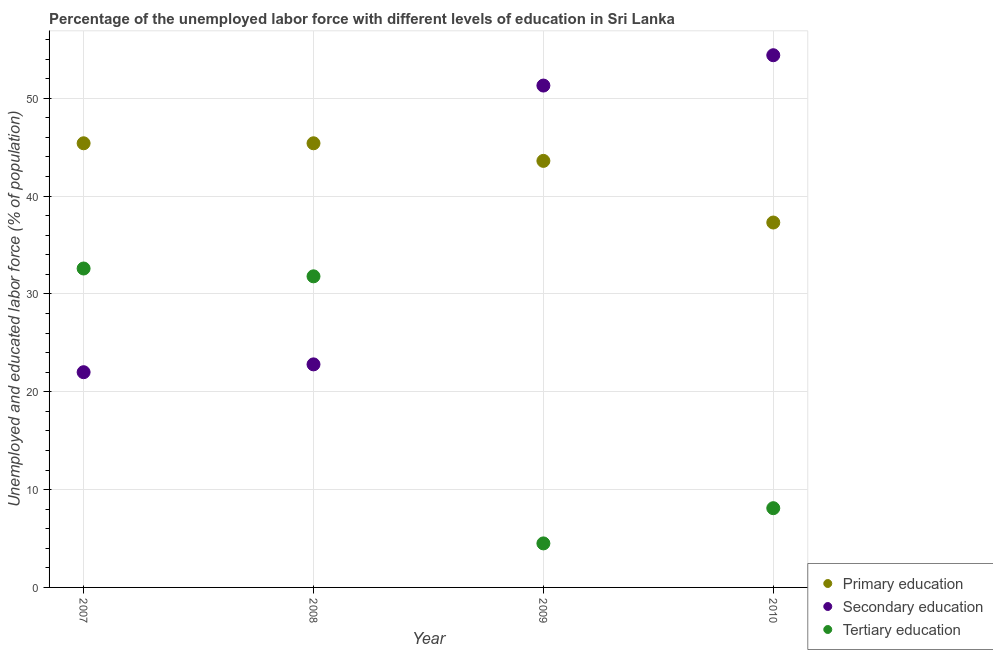How many different coloured dotlines are there?
Give a very brief answer. 3. Across all years, what is the maximum percentage of labor force who received secondary education?
Make the answer very short. 54.4. Across all years, what is the minimum percentage of labor force who received primary education?
Offer a very short reply. 37.3. What is the total percentage of labor force who received primary education in the graph?
Provide a succinct answer. 171.7. What is the difference between the percentage of labor force who received tertiary education in 2007 and that in 2009?
Keep it short and to the point. 28.1. What is the difference between the percentage of labor force who received primary education in 2007 and the percentage of labor force who received secondary education in 2009?
Offer a very short reply. -5.9. What is the average percentage of labor force who received secondary education per year?
Provide a succinct answer. 37.62. In the year 2008, what is the difference between the percentage of labor force who received primary education and percentage of labor force who received secondary education?
Provide a short and direct response. 22.6. What is the ratio of the percentage of labor force who received primary education in 2008 to that in 2010?
Offer a very short reply. 1.22. Is the percentage of labor force who received tertiary education in 2009 less than that in 2010?
Your answer should be compact. Yes. Is the difference between the percentage of labor force who received primary education in 2009 and 2010 greater than the difference between the percentage of labor force who received secondary education in 2009 and 2010?
Make the answer very short. Yes. What is the difference between the highest and the second highest percentage of labor force who received tertiary education?
Offer a terse response. 0.8. What is the difference between the highest and the lowest percentage of labor force who received primary education?
Give a very brief answer. 8.1. In how many years, is the percentage of labor force who received primary education greater than the average percentage of labor force who received primary education taken over all years?
Provide a succinct answer. 3. Is it the case that in every year, the sum of the percentage of labor force who received primary education and percentage of labor force who received secondary education is greater than the percentage of labor force who received tertiary education?
Make the answer very short. Yes. Does the percentage of labor force who received primary education monotonically increase over the years?
Ensure brevity in your answer.  No. Is the percentage of labor force who received primary education strictly less than the percentage of labor force who received tertiary education over the years?
Provide a succinct answer. No. How many dotlines are there?
Offer a terse response. 3. How many years are there in the graph?
Offer a very short reply. 4. Are the values on the major ticks of Y-axis written in scientific E-notation?
Offer a very short reply. No. Does the graph contain any zero values?
Keep it short and to the point. No. Where does the legend appear in the graph?
Your answer should be very brief. Bottom right. How are the legend labels stacked?
Your response must be concise. Vertical. What is the title of the graph?
Give a very brief answer. Percentage of the unemployed labor force with different levels of education in Sri Lanka. Does "Wage workers" appear as one of the legend labels in the graph?
Ensure brevity in your answer.  No. What is the label or title of the X-axis?
Your response must be concise. Year. What is the label or title of the Y-axis?
Provide a succinct answer. Unemployed and educated labor force (% of population). What is the Unemployed and educated labor force (% of population) of Primary education in 2007?
Offer a very short reply. 45.4. What is the Unemployed and educated labor force (% of population) of Secondary education in 2007?
Provide a short and direct response. 22. What is the Unemployed and educated labor force (% of population) in Tertiary education in 2007?
Your response must be concise. 32.6. What is the Unemployed and educated labor force (% of population) in Primary education in 2008?
Your response must be concise. 45.4. What is the Unemployed and educated labor force (% of population) of Secondary education in 2008?
Your response must be concise. 22.8. What is the Unemployed and educated labor force (% of population) of Tertiary education in 2008?
Keep it short and to the point. 31.8. What is the Unemployed and educated labor force (% of population) in Primary education in 2009?
Keep it short and to the point. 43.6. What is the Unemployed and educated labor force (% of population) in Secondary education in 2009?
Keep it short and to the point. 51.3. What is the Unemployed and educated labor force (% of population) of Tertiary education in 2009?
Make the answer very short. 4.5. What is the Unemployed and educated labor force (% of population) in Primary education in 2010?
Ensure brevity in your answer.  37.3. What is the Unemployed and educated labor force (% of population) of Secondary education in 2010?
Offer a very short reply. 54.4. What is the Unemployed and educated labor force (% of population) in Tertiary education in 2010?
Your answer should be compact. 8.1. Across all years, what is the maximum Unemployed and educated labor force (% of population) of Primary education?
Provide a short and direct response. 45.4. Across all years, what is the maximum Unemployed and educated labor force (% of population) in Secondary education?
Your answer should be very brief. 54.4. Across all years, what is the maximum Unemployed and educated labor force (% of population) of Tertiary education?
Offer a very short reply. 32.6. Across all years, what is the minimum Unemployed and educated labor force (% of population) of Primary education?
Give a very brief answer. 37.3. What is the total Unemployed and educated labor force (% of population) in Primary education in the graph?
Offer a terse response. 171.7. What is the total Unemployed and educated labor force (% of population) of Secondary education in the graph?
Your answer should be very brief. 150.5. What is the difference between the Unemployed and educated labor force (% of population) in Secondary education in 2007 and that in 2008?
Your answer should be very brief. -0.8. What is the difference between the Unemployed and educated labor force (% of population) in Tertiary education in 2007 and that in 2008?
Your response must be concise. 0.8. What is the difference between the Unemployed and educated labor force (% of population) of Primary education in 2007 and that in 2009?
Ensure brevity in your answer.  1.8. What is the difference between the Unemployed and educated labor force (% of population) in Secondary education in 2007 and that in 2009?
Provide a short and direct response. -29.3. What is the difference between the Unemployed and educated labor force (% of population) in Tertiary education in 2007 and that in 2009?
Give a very brief answer. 28.1. What is the difference between the Unemployed and educated labor force (% of population) in Primary education in 2007 and that in 2010?
Offer a very short reply. 8.1. What is the difference between the Unemployed and educated labor force (% of population) in Secondary education in 2007 and that in 2010?
Provide a succinct answer. -32.4. What is the difference between the Unemployed and educated labor force (% of population) in Tertiary education in 2007 and that in 2010?
Your answer should be very brief. 24.5. What is the difference between the Unemployed and educated labor force (% of population) in Secondary education in 2008 and that in 2009?
Ensure brevity in your answer.  -28.5. What is the difference between the Unemployed and educated labor force (% of population) of Tertiary education in 2008 and that in 2009?
Give a very brief answer. 27.3. What is the difference between the Unemployed and educated labor force (% of population) of Primary education in 2008 and that in 2010?
Your answer should be compact. 8.1. What is the difference between the Unemployed and educated labor force (% of population) of Secondary education in 2008 and that in 2010?
Give a very brief answer. -31.6. What is the difference between the Unemployed and educated labor force (% of population) of Tertiary education in 2008 and that in 2010?
Your answer should be very brief. 23.7. What is the difference between the Unemployed and educated labor force (% of population) of Primary education in 2009 and that in 2010?
Ensure brevity in your answer.  6.3. What is the difference between the Unemployed and educated labor force (% of population) of Secondary education in 2009 and that in 2010?
Your response must be concise. -3.1. What is the difference between the Unemployed and educated labor force (% of population) of Tertiary education in 2009 and that in 2010?
Your answer should be compact. -3.6. What is the difference between the Unemployed and educated labor force (% of population) of Primary education in 2007 and the Unemployed and educated labor force (% of population) of Secondary education in 2008?
Give a very brief answer. 22.6. What is the difference between the Unemployed and educated labor force (% of population) of Secondary education in 2007 and the Unemployed and educated labor force (% of population) of Tertiary education in 2008?
Make the answer very short. -9.8. What is the difference between the Unemployed and educated labor force (% of population) of Primary education in 2007 and the Unemployed and educated labor force (% of population) of Tertiary education in 2009?
Your response must be concise. 40.9. What is the difference between the Unemployed and educated labor force (% of population) in Secondary education in 2007 and the Unemployed and educated labor force (% of population) in Tertiary education in 2009?
Offer a terse response. 17.5. What is the difference between the Unemployed and educated labor force (% of population) of Primary education in 2007 and the Unemployed and educated labor force (% of population) of Secondary education in 2010?
Your response must be concise. -9. What is the difference between the Unemployed and educated labor force (% of population) in Primary education in 2007 and the Unemployed and educated labor force (% of population) in Tertiary education in 2010?
Offer a very short reply. 37.3. What is the difference between the Unemployed and educated labor force (% of population) in Secondary education in 2007 and the Unemployed and educated labor force (% of population) in Tertiary education in 2010?
Make the answer very short. 13.9. What is the difference between the Unemployed and educated labor force (% of population) of Primary education in 2008 and the Unemployed and educated labor force (% of population) of Secondary education in 2009?
Make the answer very short. -5.9. What is the difference between the Unemployed and educated labor force (% of population) in Primary education in 2008 and the Unemployed and educated labor force (% of population) in Tertiary education in 2009?
Provide a short and direct response. 40.9. What is the difference between the Unemployed and educated labor force (% of population) in Primary education in 2008 and the Unemployed and educated labor force (% of population) in Secondary education in 2010?
Your response must be concise. -9. What is the difference between the Unemployed and educated labor force (% of population) in Primary education in 2008 and the Unemployed and educated labor force (% of population) in Tertiary education in 2010?
Your answer should be very brief. 37.3. What is the difference between the Unemployed and educated labor force (% of population) of Secondary education in 2008 and the Unemployed and educated labor force (% of population) of Tertiary education in 2010?
Your answer should be very brief. 14.7. What is the difference between the Unemployed and educated labor force (% of population) in Primary education in 2009 and the Unemployed and educated labor force (% of population) in Tertiary education in 2010?
Provide a short and direct response. 35.5. What is the difference between the Unemployed and educated labor force (% of population) of Secondary education in 2009 and the Unemployed and educated labor force (% of population) of Tertiary education in 2010?
Provide a short and direct response. 43.2. What is the average Unemployed and educated labor force (% of population) of Primary education per year?
Provide a succinct answer. 42.92. What is the average Unemployed and educated labor force (% of population) of Secondary education per year?
Offer a very short reply. 37.62. What is the average Unemployed and educated labor force (% of population) in Tertiary education per year?
Provide a short and direct response. 19.25. In the year 2007, what is the difference between the Unemployed and educated labor force (% of population) of Primary education and Unemployed and educated labor force (% of population) of Secondary education?
Provide a short and direct response. 23.4. In the year 2008, what is the difference between the Unemployed and educated labor force (% of population) of Primary education and Unemployed and educated labor force (% of population) of Secondary education?
Give a very brief answer. 22.6. In the year 2008, what is the difference between the Unemployed and educated labor force (% of population) of Primary education and Unemployed and educated labor force (% of population) of Tertiary education?
Give a very brief answer. 13.6. In the year 2008, what is the difference between the Unemployed and educated labor force (% of population) of Secondary education and Unemployed and educated labor force (% of population) of Tertiary education?
Provide a succinct answer. -9. In the year 2009, what is the difference between the Unemployed and educated labor force (% of population) in Primary education and Unemployed and educated labor force (% of population) in Tertiary education?
Your answer should be very brief. 39.1. In the year 2009, what is the difference between the Unemployed and educated labor force (% of population) in Secondary education and Unemployed and educated labor force (% of population) in Tertiary education?
Your answer should be very brief. 46.8. In the year 2010, what is the difference between the Unemployed and educated labor force (% of population) of Primary education and Unemployed and educated labor force (% of population) of Secondary education?
Ensure brevity in your answer.  -17.1. In the year 2010, what is the difference between the Unemployed and educated labor force (% of population) in Primary education and Unemployed and educated labor force (% of population) in Tertiary education?
Make the answer very short. 29.2. In the year 2010, what is the difference between the Unemployed and educated labor force (% of population) in Secondary education and Unemployed and educated labor force (% of population) in Tertiary education?
Provide a succinct answer. 46.3. What is the ratio of the Unemployed and educated labor force (% of population) of Primary education in 2007 to that in 2008?
Offer a terse response. 1. What is the ratio of the Unemployed and educated labor force (% of population) of Secondary education in 2007 to that in 2008?
Give a very brief answer. 0.96. What is the ratio of the Unemployed and educated labor force (% of population) in Tertiary education in 2007 to that in 2008?
Make the answer very short. 1.03. What is the ratio of the Unemployed and educated labor force (% of population) in Primary education in 2007 to that in 2009?
Ensure brevity in your answer.  1.04. What is the ratio of the Unemployed and educated labor force (% of population) in Secondary education in 2007 to that in 2009?
Give a very brief answer. 0.43. What is the ratio of the Unemployed and educated labor force (% of population) of Tertiary education in 2007 to that in 2009?
Provide a succinct answer. 7.24. What is the ratio of the Unemployed and educated labor force (% of population) of Primary education in 2007 to that in 2010?
Give a very brief answer. 1.22. What is the ratio of the Unemployed and educated labor force (% of population) in Secondary education in 2007 to that in 2010?
Your answer should be compact. 0.4. What is the ratio of the Unemployed and educated labor force (% of population) of Tertiary education in 2007 to that in 2010?
Make the answer very short. 4.02. What is the ratio of the Unemployed and educated labor force (% of population) of Primary education in 2008 to that in 2009?
Offer a very short reply. 1.04. What is the ratio of the Unemployed and educated labor force (% of population) in Secondary education in 2008 to that in 2009?
Ensure brevity in your answer.  0.44. What is the ratio of the Unemployed and educated labor force (% of population) of Tertiary education in 2008 to that in 2009?
Your answer should be compact. 7.07. What is the ratio of the Unemployed and educated labor force (% of population) of Primary education in 2008 to that in 2010?
Your answer should be compact. 1.22. What is the ratio of the Unemployed and educated labor force (% of population) of Secondary education in 2008 to that in 2010?
Your answer should be very brief. 0.42. What is the ratio of the Unemployed and educated labor force (% of population) in Tertiary education in 2008 to that in 2010?
Your answer should be very brief. 3.93. What is the ratio of the Unemployed and educated labor force (% of population) in Primary education in 2009 to that in 2010?
Your response must be concise. 1.17. What is the ratio of the Unemployed and educated labor force (% of population) in Secondary education in 2009 to that in 2010?
Offer a terse response. 0.94. What is the ratio of the Unemployed and educated labor force (% of population) of Tertiary education in 2009 to that in 2010?
Your answer should be very brief. 0.56. What is the difference between the highest and the second highest Unemployed and educated labor force (% of population) in Primary education?
Ensure brevity in your answer.  0. What is the difference between the highest and the second highest Unemployed and educated labor force (% of population) of Secondary education?
Provide a short and direct response. 3.1. What is the difference between the highest and the second highest Unemployed and educated labor force (% of population) of Tertiary education?
Provide a succinct answer. 0.8. What is the difference between the highest and the lowest Unemployed and educated labor force (% of population) in Primary education?
Offer a terse response. 8.1. What is the difference between the highest and the lowest Unemployed and educated labor force (% of population) of Secondary education?
Keep it short and to the point. 32.4. What is the difference between the highest and the lowest Unemployed and educated labor force (% of population) in Tertiary education?
Provide a short and direct response. 28.1. 